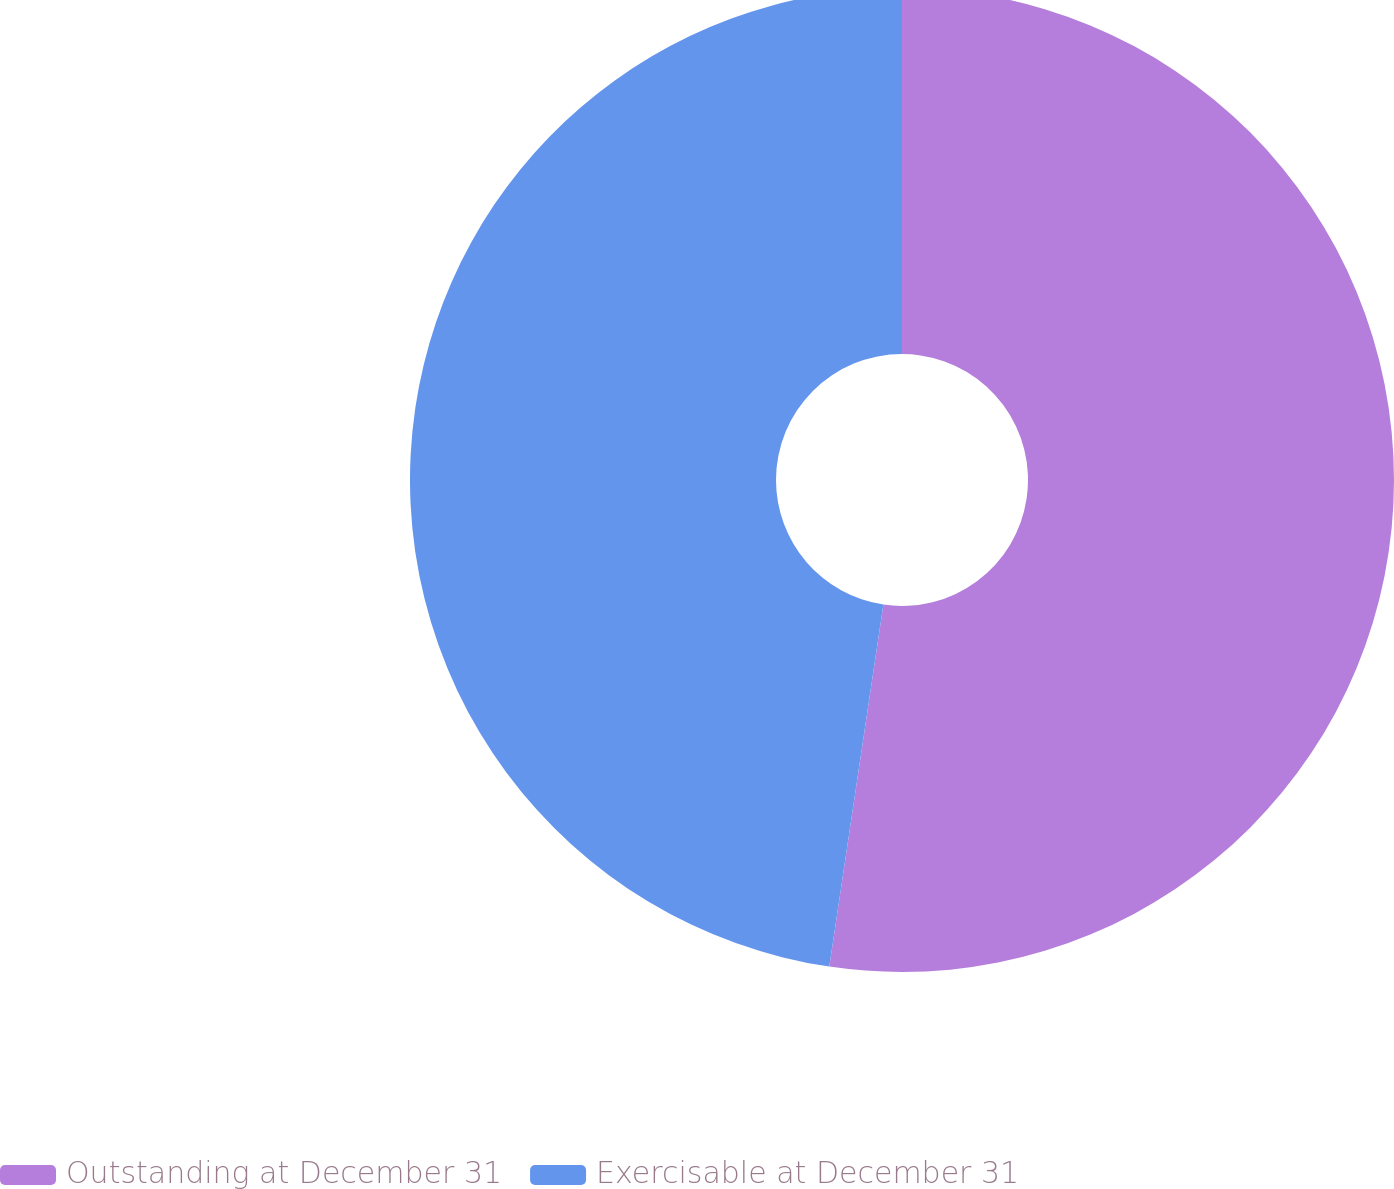Convert chart. <chart><loc_0><loc_0><loc_500><loc_500><pie_chart><fcel>Outstanding at December 31<fcel>Exercisable at December 31<nl><fcel>52.36%<fcel>47.64%<nl></chart> 